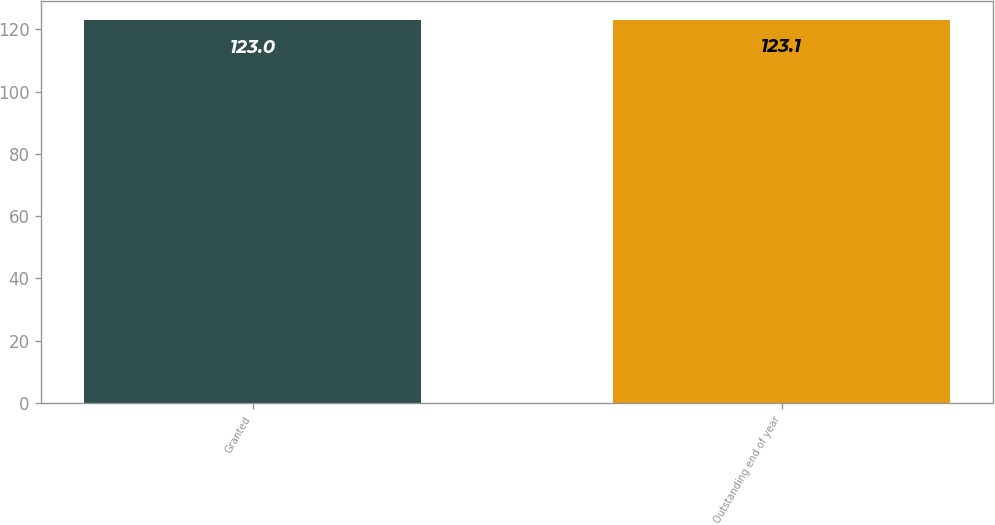Convert chart. <chart><loc_0><loc_0><loc_500><loc_500><bar_chart><fcel>Granted<fcel>Outstanding end of year<nl><fcel>123<fcel>123.1<nl></chart> 